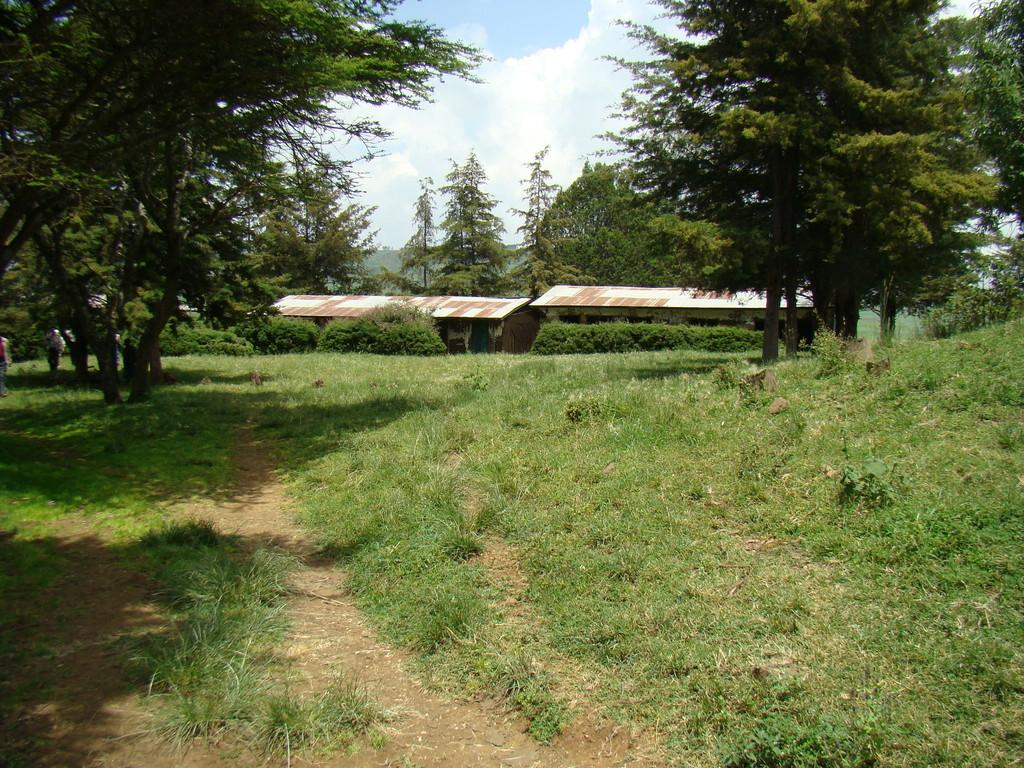What type of terrain is visible in the image? There is an open ground with grass in the image. What other natural elements can be seen in the image? There are trees in the image. What type of structures are present in the image? There are houses in the center of the image. What is visible at the top of the image? The sky is visible at the top of the image. What type of behavior can be observed in the spiders in the image? There are no spiders present in the image, so their behavior cannot be observed. 